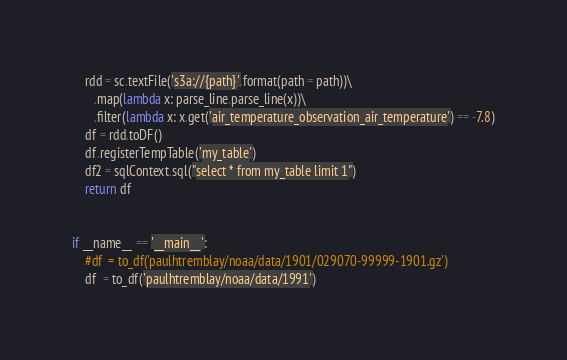Convert code to text. <code><loc_0><loc_0><loc_500><loc_500><_Python_>    rdd = sc.textFile('s3a://{path}'.format(path = path))\
       .map(lambda x: parse_line.parse_line(x))\
       .filter(lambda x: x.get('air_temperature_observation_air_temperature') == -7.8)
    df = rdd.toDF()
    df.registerTempTable('my_table')
    df2 = sqlContext.sql("select * from my_table limit 1")
    return df


if __name__ == '__main__':
    #df  = to_df('paulhtremblay/noaa/data/1901/029070-99999-1901.gz')
    df  = to_df('paulhtremblay/noaa/data/1991')
</code> 